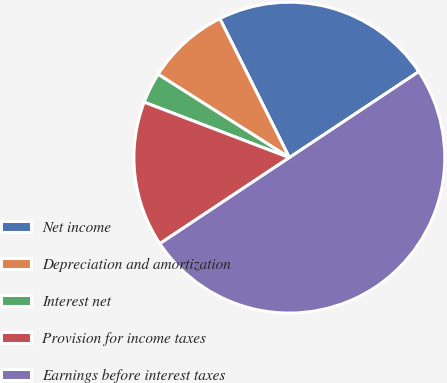Convert chart to OTSL. <chart><loc_0><loc_0><loc_500><loc_500><pie_chart><fcel>Net income<fcel>Depreciation and amortization<fcel>Interest net<fcel>Provision for income taxes<fcel>Earnings before interest taxes<nl><fcel>23.05%<fcel>8.61%<fcel>3.2%<fcel>15.14%<fcel>50.0%<nl></chart> 